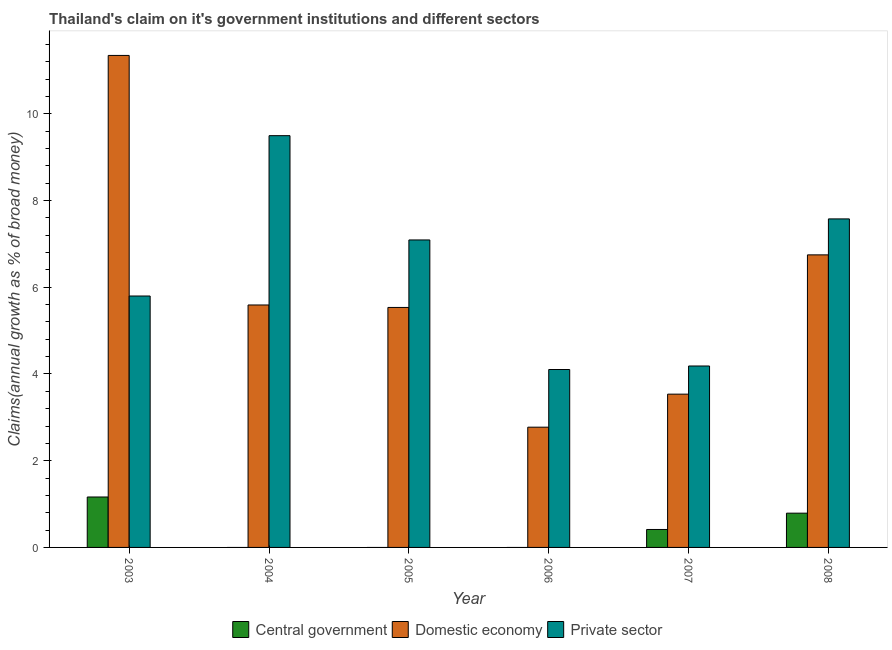How many groups of bars are there?
Offer a terse response. 6. Are the number of bars per tick equal to the number of legend labels?
Make the answer very short. No. Are the number of bars on each tick of the X-axis equal?
Provide a short and direct response. No. What is the label of the 5th group of bars from the left?
Your answer should be compact. 2007. What is the percentage of claim on the private sector in 2007?
Give a very brief answer. 4.18. Across all years, what is the maximum percentage of claim on the central government?
Your answer should be compact. 1.16. Across all years, what is the minimum percentage of claim on the central government?
Provide a succinct answer. 0. In which year was the percentage of claim on the domestic economy maximum?
Offer a terse response. 2003. What is the total percentage of claim on the central government in the graph?
Your answer should be very brief. 2.37. What is the difference between the percentage of claim on the domestic economy in 2004 and that in 2008?
Provide a short and direct response. -1.16. What is the difference between the percentage of claim on the central government in 2008 and the percentage of claim on the private sector in 2004?
Your answer should be compact. 0.79. What is the average percentage of claim on the domestic economy per year?
Your response must be concise. 5.92. What is the ratio of the percentage of claim on the domestic economy in 2006 to that in 2007?
Your answer should be compact. 0.78. Is the percentage of claim on the domestic economy in 2007 less than that in 2008?
Your response must be concise. Yes. Is the difference between the percentage of claim on the private sector in 2007 and 2008 greater than the difference between the percentage of claim on the central government in 2007 and 2008?
Offer a very short reply. No. What is the difference between the highest and the second highest percentage of claim on the central government?
Your answer should be compact. 0.37. What is the difference between the highest and the lowest percentage of claim on the private sector?
Provide a short and direct response. 5.39. Is the sum of the percentage of claim on the domestic economy in 2004 and 2006 greater than the maximum percentage of claim on the central government across all years?
Ensure brevity in your answer.  No. Is it the case that in every year, the sum of the percentage of claim on the central government and percentage of claim on the domestic economy is greater than the percentage of claim on the private sector?
Offer a terse response. No. How many years are there in the graph?
Ensure brevity in your answer.  6. What is the difference between two consecutive major ticks on the Y-axis?
Offer a terse response. 2. Are the values on the major ticks of Y-axis written in scientific E-notation?
Ensure brevity in your answer.  No. Where does the legend appear in the graph?
Your answer should be compact. Bottom center. How many legend labels are there?
Your answer should be compact. 3. What is the title of the graph?
Your response must be concise. Thailand's claim on it's government institutions and different sectors. What is the label or title of the X-axis?
Offer a terse response. Year. What is the label or title of the Y-axis?
Offer a terse response. Claims(annual growth as % of broad money). What is the Claims(annual growth as % of broad money) of Central government in 2003?
Provide a succinct answer. 1.16. What is the Claims(annual growth as % of broad money) in Domestic economy in 2003?
Keep it short and to the point. 11.35. What is the Claims(annual growth as % of broad money) in Private sector in 2003?
Provide a succinct answer. 5.8. What is the Claims(annual growth as % of broad money) in Domestic economy in 2004?
Your answer should be very brief. 5.59. What is the Claims(annual growth as % of broad money) of Private sector in 2004?
Your answer should be very brief. 9.5. What is the Claims(annual growth as % of broad money) in Domestic economy in 2005?
Offer a terse response. 5.53. What is the Claims(annual growth as % of broad money) of Private sector in 2005?
Provide a short and direct response. 7.09. What is the Claims(annual growth as % of broad money) of Domestic economy in 2006?
Your answer should be compact. 2.77. What is the Claims(annual growth as % of broad money) of Private sector in 2006?
Keep it short and to the point. 4.1. What is the Claims(annual growth as % of broad money) in Central government in 2007?
Your answer should be very brief. 0.41. What is the Claims(annual growth as % of broad money) in Domestic economy in 2007?
Ensure brevity in your answer.  3.54. What is the Claims(annual growth as % of broad money) in Private sector in 2007?
Your answer should be compact. 4.18. What is the Claims(annual growth as % of broad money) of Central government in 2008?
Offer a terse response. 0.79. What is the Claims(annual growth as % of broad money) of Domestic economy in 2008?
Offer a terse response. 6.75. What is the Claims(annual growth as % of broad money) in Private sector in 2008?
Keep it short and to the point. 7.58. Across all years, what is the maximum Claims(annual growth as % of broad money) in Central government?
Ensure brevity in your answer.  1.16. Across all years, what is the maximum Claims(annual growth as % of broad money) of Domestic economy?
Offer a terse response. 11.35. Across all years, what is the maximum Claims(annual growth as % of broad money) in Private sector?
Keep it short and to the point. 9.5. Across all years, what is the minimum Claims(annual growth as % of broad money) in Central government?
Your response must be concise. 0. Across all years, what is the minimum Claims(annual growth as % of broad money) in Domestic economy?
Keep it short and to the point. 2.77. Across all years, what is the minimum Claims(annual growth as % of broad money) of Private sector?
Provide a short and direct response. 4.1. What is the total Claims(annual growth as % of broad money) of Central government in the graph?
Provide a succinct answer. 2.37. What is the total Claims(annual growth as % of broad money) in Domestic economy in the graph?
Provide a succinct answer. 35.53. What is the total Claims(annual growth as % of broad money) of Private sector in the graph?
Keep it short and to the point. 38.25. What is the difference between the Claims(annual growth as % of broad money) in Domestic economy in 2003 and that in 2004?
Your answer should be compact. 5.76. What is the difference between the Claims(annual growth as % of broad money) of Private sector in 2003 and that in 2004?
Ensure brevity in your answer.  -3.7. What is the difference between the Claims(annual growth as % of broad money) of Domestic economy in 2003 and that in 2005?
Offer a very short reply. 5.81. What is the difference between the Claims(annual growth as % of broad money) of Private sector in 2003 and that in 2005?
Provide a succinct answer. -1.29. What is the difference between the Claims(annual growth as % of broad money) of Domestic economy in 2003 and that in 2006?
Your response must be concise. 8.57. What is the difference between the Claims(annual growth as % of broad money) in Private sector in 2003 and that in 2006?
Provide a succinct answer. 1.7. What is the difference between the Claims(annual growth as % of broad money) of Central government in 2003 and that in 2007?
Provide a short and direct response. 0.75. What is the difference between the Claims(annual growth as % of broad money) in Domestic economy in 2003 and that in 2007?
Your answer should be very brief. 7.81. What is the difference between the Claims(annual growth as % of broad money) of Private sector in 2003 and that in 2007?
Make the answer very short. 1.61. What is the difference between the Claims(annual growth as % of broad money) of Central government in 2003 and that in 2008?
Your response must be concise. 0.37. What is the difference between the Claims(annual growth as % of broad money) in Domestic economy in 2003 and that in 2008?
Your answer should be compact. 4.6. What is the difference between the Claims(annual growth as % of broad money) of Private sector in 2003 and that in 2008?
Make the answer very short. -1.78. What is the difference between the Claims(annual growth as % of broad money) in Domestic economy in 2004 and that in 2005?
Make the answer very short. 0.06. What is the difference between the Claims(annual growth as % of broad money) of Private sector in 2004 and that in 2005?
Make the answer very short. 2.41. What is the difference between the Claims(annual growth as % of broad money) in Domestic economy in 2004 and that in 2006?
Ensure brevity in your answer.  2.82. What is the difference between the Claims(annual growth as % of broad money) in Private sector in 2004 and that in 2006?
Offer a very short reply. 5.39. What is the difference between the Claims(annual growth as % of broad money) of Domestic economy in 2004 and that in 2007?
Ensure brevity in your answer.  2.06. What is the difference between the Claims(annual growth as % of broad money) of Private sector in 2004 and that in 2007?
Keep it short and to the point. 5.31. What is the difference between the Claims(annual growth as % of broad money) of Domestic economy in 2004 and that in 2008?
Provide a short and direct response. -1.16. What is the difference between the Claims(annual growth as % of broad money) in Private sector in 2004 and that in 2008?
Offer a very short reply. 1.92. What is the difference between the Claims(annual growth as % of broad money) of Domestic economy in 2005 and that in 2006?
Your response must be concise. 2.76. What is the difference between the Claims(annual growth as % of broad money) in Private sector in 2005 and that in 2006?
Offer a terse response. 2.99. What is the difference between the Claims(annual growth as % of broad money) of Domestic economy in 2005 and that in 2007?
Offer a very short reply. 2. What is the difference between the Claims(annual growth as % of broad money) in Private sector in 2005 and that in 2007?
Offer a terse response. 2.91. What is the difference between the Claims(annual growth as % of broad money) in Domestic economy in 2005 and that in 2008?
Offer a terse response. -1.21. What is the difference between the Claims(annual growth as % of broad money) in Private sector in 2005 and that in 2008?
Your answer should be compact. -0.49. What is the difference between the Claims(annual growth as % of broad money) of Domestic economy in 2006 and that in 2007?
Offer a very short reply. -0.76. What is the difference between the Claims(annual growth as % of broad money) in Private sector in 2006 and that in 2007?
Your answer should be very brief. -0.08. What is the difference between the Claims(annual growth as % of broad money) of Domestic economy in 2006 and that in 2008?
Provide a succinct answer. -3.97. What is the difference between the Claims(annual growth as % of broad money) in Private sector in 2006 and that in 2008?
Your answer should be compact. -3.47. What is the difference between the Claims(annual growth as % of broad money) of Central government in 2007 and that in 2008?
Offer a terse response. -0.38. What is the difference between the Claims(annual growth as % of broad money) in Domestic economy in 2007 and that in 2008?
Provide a short and direct response. -3.21. What is the difference between the Claims(annual growth as % of broad money) of Private sector in 2007 and that in 2008?
Your response must be concise. -3.39. What is the difference between the Claims(annual growth as % of broad money) in Central government in 2003 and the Claims(annual growth as % of broad money) in Domestic economy in 2004?
Offer a very short reply. -4.43. What is the difference between the Claims(annual growth as % of broad money) of Central government in 2003 and the Claims(annual growth as % of broad money) of Private sector in 2004?
Give a very brief answer. -8.33. What is the difference between the Claims(annual growth as % of broad money) of Domestic economy in 2003 and the Claims(annual growth as % of broad money) of Private sector in 2004?
Give a very brief answer. 1.85. What is the difference between the Claims(annual growth as % of broad money) of Central government in 2003 and the Claims(annual growth as % of broad money) of Domestic economy in 2005?
Provide a short and direct response. -4.37. What is the difference between the Claims(annual growth as % of broad money) in Central government in 2003 and the Claims(annual growth as % of broad money) in Private sector in 2005?
Offer a terse response. -5.93. What is the difference between the Claims(annual growth as % of broad money) of Domestic economy in 2003 and the Claims(annual growth as % of broad money) of Private sector in 2005?
Provide a succinct answer. 4.26. What is the difference between the Claims(annual growth as % of broad money) of Central government in 2003 and the Claims(annual growth as % of broad money) of Domestic economy in 2006?
Provide a short and direct response. -1.61. What is the difference between the Claims(annual growth as % of broad money) of Central government in 2003 and the Claims(annual growth as % of broad money) of Private sector in 2006?
Keep it short and to the point. -2.94. What is the difference between the Claims(annual growth as % of broad money) in Domestic economy in 2003 and the Claims(annual growth as % of broad money) in Private sector in 2006?
Your answer should be compact. 7.24. What is the difference between the Claims(annual growth as % of broad money) in Central government in 2003 and the Claims(annual growth as % of broad money) in Domestic economy in 2007?
Keep it short and to the point. -2.37. What is the difference between the Claims(annual growth as % of broad money) in Central government in 2003 and the Claims(annual growth as % of broad money) in Private sector in 2007?
Keep it short and to the point. -3.02. What is the difference between the Claims(annual growth as % of broad money) of Domestic economy in 2003 and the Claims(annual growth as % of broad money) of Private sector in 2007?
Keep it short and to the point. 7.16. What is the difference between the Claims(annual growth as % of broad money) in Central government in 2003 and the Claims(annual growth as % of broad money) in Domestic economy in 2008?
Provide a short and direct response. -5.58. What is the difference between the Claims(annual growth as % of broad money) of Central government in 2003 and the Claims(annual growth as % of broad money) of Private sector in 2008?
Make the answer very short. -6.41. What is the difference between the Claims(annual growth as % of broad money) of Domestic economy in 2003 and the Claims(annual growth as % of broad money) of Private sector in 2008?
Your answer should be very brief. 3.77. What is the difference between the Claims(annual growth as % of broad money) in Domestic economy in 2004 and the Claims(annual growth as % of broad money) in Private sector in 2005?
Keep it short and to the point. -1.5. What is the difference between the Claims(annual growth as % of broad money) in Domestic economy in 2004 and the Claims(annual growth as % of broad money) in Private sector in 2006?
Offer a terse response. 1.49. What is the difference between the Claims(annual growth as % of broad money) in Domestic economy in 2004 and the Claims(annual growth as % of broad money) in Private sector in 2007?
Give a very brief answer. 1.41. What is the difference between the Claims(annual growth as % of broad money) in Domestic economy in 2004 and the Claims(annual growth as % of broad money) in Private sector in 2008?
Your answer should be very brief. -1.99. What is the difference between the Claims(annual growth as % of broad money) in Domestic economy in 2005 and the Claims(annual growth as % of broad money) in Private sector in 2006?
Give a very brief answer. 1.43. What is the difference between the Claims(annual growth as % of broad money) in Domestic economy in 2005 and the Claims(annual growth as % of broad money) in Private sector in 2007?
Your response must be concise. 1.35. What is the difference between the Claims(annual growth as % of broad money) in Domestic economy in 2005 and the Claims(annual growth as % of broad money) in Private sector in 2008?
Your answer should be compact. -2.04. What is the difference between the Claims(annual growth as % of broad money) of Domestic economy in 2006 and the Claims(annual growth as % of broad money) of Private sector in 2007?
Your response must be concise. -1.41. What is the difference between the Claims(annual growth as % of broad money) in Domestic economy in 2006 and the Claims(annual growth as % of broad money) in Private sector in 2008?
Your answer should be very brief. -4.8. What is the difference between the Claims(annual growth as % of broad money) of Central government in 2007 and the Claims(annual growth as % of broad money) of Domestic economy in 2008?
Provide a short and direct response. -6.33. What is the difference between the Claims(annual growth as % of broad money) of Central government in 2007 and the Claims(annual growth as % of broad money) of Private sector in 2008?
Keep it short and to the point. -7.16. What is the difference between the Claims(annual growth as % of broad money) in Domestic economy in 2007 and the Claims(annual growth as % of broad money) in Private sector in 2008?
Your response must be concise. -4.04. What is the average Claims(annual growth as % of broad money) of Central government per year?
Provide a short and direct response. 0.39. What is the average Claims(annual growth as % of broad money) in Domestic economy per year?
Offer a very short reply. 5.92. What is the average Claims(annual growth as % of broad money) of Private sector per year?
Provide a short and direct response. 6.38. In the year 2003, what is the difference between the Claims(annual growth as % of broad money) in Central government and Claims(annual growth as % of broad money) in Domestic economy?
Your answer should be very brief. -10.18. In the year 2003, what is the difference between the Claims(annual growth as % of broad money) in Central government and Claims(annual growth as % of broad money) in Private sector?
Keep it short and to the point. -4.64. In the year 2003, what is the difference between the Claims(annual growth as % of broad money) of Domestic economy and Claims(annual growth as % of broad money) of Private sector?
Offer a terse response. 5.55. In the year 2004, what is the difference between the Claims(annual growth as % of broad money) in Domestic economy and Claims(annual growth as % of broad money) in Private sector?
Offer a very short reply. -3.9. In the year 2005, what is the difference between the Claims(annual growth as % of broad money) of Domestic economy and Claims(annual growth as % of broad money) of Private sector?
Your response must be concise. -1.56. In the year 2006, what is the difference between the Claims(annual growth as % of broad money) in Domestic economy and Claims(annual growth as % of broad money) in Private sector?
Keep it short and to the point. -1.33. In the year 2007, what is the difference between the Claims(annual growth as % of broad money) of Central government and Claims(annual growth as % of broad money) of Domestic economy?
Your answer should be very brief. -3.12. In the year 2007, what is the difference between the Claims(annual growth as % of broad money) in Central government and Claims(annual growth as % of broad money) in Private sector?
Your answer should be compact. -3.77. In the year 2007, what is the difference between the Claims(annual growth as % of broad money) in Domestic economy and Claims(annual growth as % of broad money) in Private sector?
Keep it short and to the point. -0.65. In the year 2008, what is the difference between the Claims(annual growth as % of broad money) of Central government and Claims(annual growth as % of broad money) of Domestic economy?
Provide a short and direct response. -5.96. In the year 2008, what is the difference between the Claims(annual growth as % of broad money) of Central government and Claims(annual growth as % of broad money) of Private sector?
Provide a short and direct response. -6.79. In the year 2008, what is the difference between the Claims(annual growth as % of broad money) of Domestic economy and Claims(annual growth as % of broad money) of Private sector?
Your answer should be compact. -0.83. What is the ratio of the Claims(annual growth as % of broad money) in Domestic economy in 2003 to that in 2004?
Give a very brief answer. 2.03. What is the ratio of the Claims(annual growth as % of broad money) of Private sector in 2003 to that in 2004?
Provide a short and direct response. 0.61. What is the ratio of the Claims(annual growth as % of broad money) of Domestic economy in 2003 to that in 2005?
Give a very brief answer. 2.05. What is the ratio of the Claims(annual growth as % of broad money) of Private sector in 2003 to that in 2005?
Your response must be concise. 0.82. What is the ratio of the Claims(annual growth as % of broad money) of Domestic economy in 2003 to that in 2006?
Offer a very short reply. 4.09. What is the ratio of the Claims(annual growth as % of broad money) of Private sector in 2003 to that in 2006?
Give a very brief answer. 1.41. What is the ratio of the Claims(annual growth as % of broad money) of Central government in 2003 to that in 2007?
Offer a very short reply. 2.81. What is the ratio of the Claims(annual growth as % of broad money) of Domestic economy in 2003 to that in 2007?
Provide a succinct answer. 3.21. What is the ratio of the Claims(annual growth as % of broad money) in Private sector in 2003 to that in 2007?
Your answer should be very brief. 1.39. What is the ratio of the Claims(annual growth as % of broad money) of Central government in 2003 to that in 2008?
Offer a very short reply. 1.47. What is the ratio of the Claims(annual growth as % of broad money) in Domestic economy in 2003 to that in 2008?
Your answer should be very brief. 1.68. What is the ratio of the Claims(annual growth as % of broad money) in Private sector in 2003 to that in 2008?
Give a very brief answer. 0.77. What is the ratio of the Claims(annual growth as % of broad money) of Domestic economy in 2004 to that in 2005?
Give a very brief answer. 1.01. What is the ratio of the Claims(annual growth as % of broad money) in Private sector in 2004 to that in 2005?
Ensure brevity in your answer.  1.34. What is the ratio of the Claims(annual growth as % of broad money) in Domestic economy in 2004 to that in 2006?
Ensure brevity in your answer.  2.02. What is the ratio of the Claims(annual growth as % of broad money) in Private sector in 2004 to that in 2006?
Your answer should be compact. 2.31. What is the ratio of the Claims(annual growth as % of broad money) of Domestic economy in 2004 to that in 2007?
Provide a short and direct response. 1.58. What is the ratio of the Claims(annual growth as % of broad money) of Private sector in 2004 to that in 2007?
Make the answer very short. 2.27. What is the ratio of the Claims(annual growth as % of broad money) in Domestic economy in 2004 to that in 2008?
Provide a short and direct response. 0.83. What is the ratio of the Claims(annual growth as % of broad money) in Private sector in 2004 to that in 2008?
Ensure brevity in your answer.  1.25. What is the ratio of the Claims(annual growth as % of broad money) in Domestic economy in 2005 to that in 2006?
Ensure brevity in your answer.  2. What is the ratio of the Claims(annual growth as % of broad money) in Private sector in 2005 to that in 2006?
Your response must be concise. 1.73. What is the ratio of the Claims(annual growth as % of broad money) in Domestic economy in 2005 to that in 2007?
Provide a short and direct response. 1.57. What is the ratio of the Claims(annual growth as % of broad money) of Private sector in 2005 to that in 2007?
Your answer should be compact. 1.69. What is the ratio of the Claims(annual growth as % of broad money) in Domestic economy in 2005 to that in 2008?
Provide a succinct answer. 0.82. What is the ratio of the Claims(annual growth as % of broad money) of Private sector in 2005 to that in 2008?
Offer a very short reply. 0.94. What is the ratio of the Claims(annual growth as % of broad money) in Domestic economy in 2006 to that in 2007?
Offer a terse response. 0.78. What is the ratio of the Claims(annual growth as % of broad money) of Private sector in 2006 to that in 2007?
Your response must be concise. 0.98. What is the ratio of the Claims(annual growth as % of broad money) in Domestic economy in 2006 to that in 2008?
Ensure brevity in your answer.  0.41. What is the ratio of the Claims(annual growth as % of broad money) of Private sector in 2006 to that in 2008?
Provide a succinct answer. 0.54. What is the ratio of the Claims(annual growth as % of broad money) in Central government in 2007 to that in 2008?
Your answer should be compact. 0.52. What is the ratio of the Claims(annual growth as % of broad money) of Domestic economy in 2007 to that in 2008?
Offer a very short reply. 0.52. What is the ratio of the Claims(annual growth as % of broad money) in Private sector in 2007 to that in 2008?
Your response must be concise. 0.55. What is the difference between the highest and the second highest Claims(annual growth as % of broad money) in Central government?
Keep it short and to the point. 0.37. What is the difference between the highest and the second highest Claims(annual growth as % of broad money) of Domestic economy?
Provide a short and direct response. 4.6. What is the difference between the highest and the second highest Claims(annual growth as % of broad money) of Private sector?
Your answer should be compact. 1.92. What is the difference between the highest and the lowest Claims(annual growth as % of broad money) in Central government?
Provide a short and direct response. 1.16. What is the difference between the highest and the lowest Claims(annual growth as % of broad money) in Domestic economy?
Offer a very short reply. 8.57. What is the difference between the highest and the lowest Claims(annual growth as % of broad money) of Private sector?
Offer a very short reply. 5.39. 